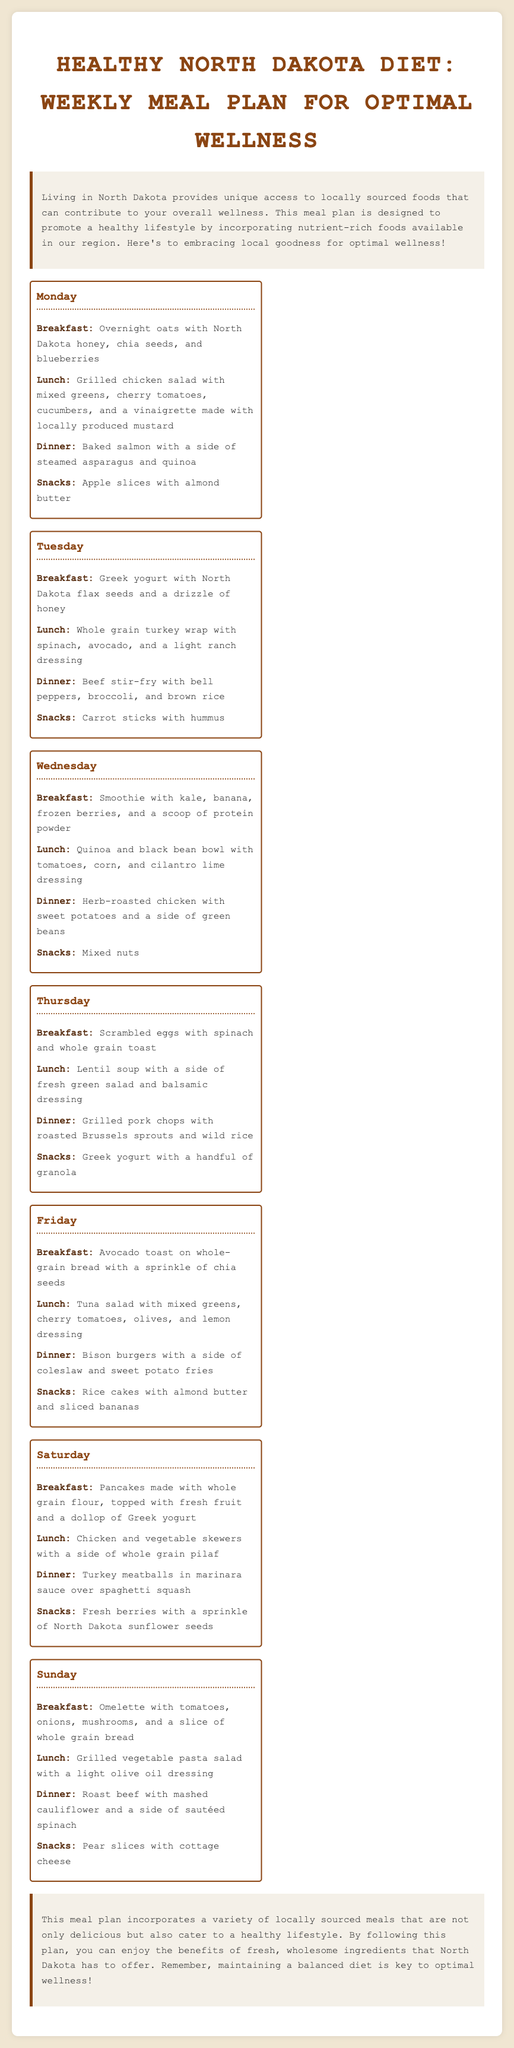What is the title of the meal plan? The title is stated in the header of the document, summarizing the content of the meal plan.
Answer: Healthy North Dakota Diet: Weekly Meal Plan for Optimal Wellness What day features a baked salmon dinner? This information requires recalling the specific meals mentioned for different days.
Answer: Monday Which snack is suggested on Tuesday? The document lists the snacks associated with each day, allowing us to identify the correct day.
Answer: Carrot sticks with hummus How many meals are listed for each day? Each day contains a structured format that consistently lists four meals.
Answer: 4 What type of dressing is used in the grilled chicken salad? The salad dressing is specified in the lunch section for Monday.
Answer: Vinaigrette What is a unique ingredient found in Wednesday's breakfast? The breakfast options on Wednesday showcase a specific smoothie blend.
Answer: Protein powder On which day is the avocado toast mentioned? This information specifies a day within the meal plan focused on breakfast options.
Answer: Friday What is the main dish listed for Sunday dinner? The dinner for Sunday is explicitly stated in the document.
Answer: Roast beef Which fruit is paired with almond butter for a snack on Monday? The document explicitly pairs snacks with their respective days, including Monday.
Answer: Apple slices 